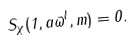Convert formula to latex. <formula><loc_0><loc_0><loc_500><loc_500>S _ { \chi } ( 1 , a \varpi ^ { l } , m ) = 0 .</formula> 